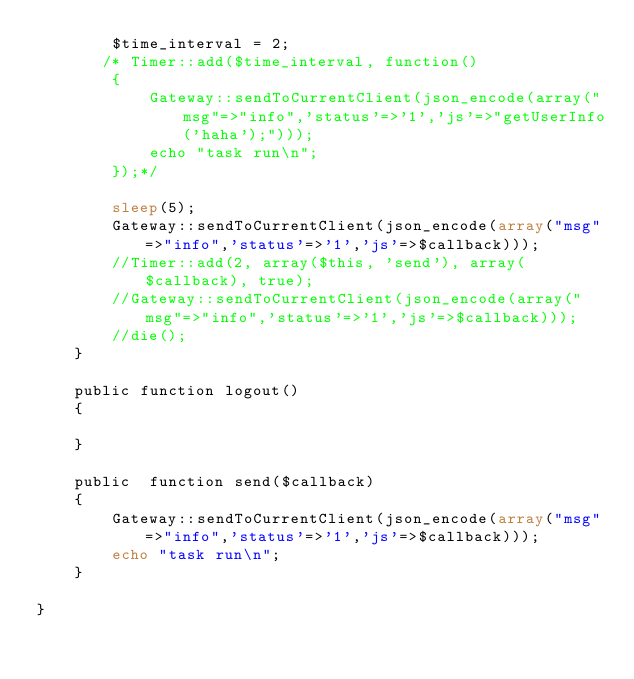Convert code to text. <code><loc_0><loc_0><loc_500><loc_500><_PHP_>        $time_interval = 2;
       /* Timer::add($time_interval, function()
        {
            Gateway::sendToCurrentClient(json_encode(array("msg"=>"info",'status'=>'1','js'=>"getUserInfo('haha');")));
            echo "task run\n";
        });*/

        sleep(5);
        Gateway::sendToCurrentClient(json_encode(array("msg"=>"info",'status'=>'1','js'=>$callback)));
        //Timer::add(2, array($this, 'send'), array($callback), true);
        //Gateway::sendToCurrentClient(json_encode(array("msg"=>"info",'status'=>'1','js'=>$callback)));
        //die();
    }

    public function logout()
    {

    }

    public  function send($callback)
    {
        Gateway::sendToCurrentClient(json_encode(array("msg"=>"info",'status'=>'1','js'=>$callback)));
        echo "task run\n";
    }

}

</code> 